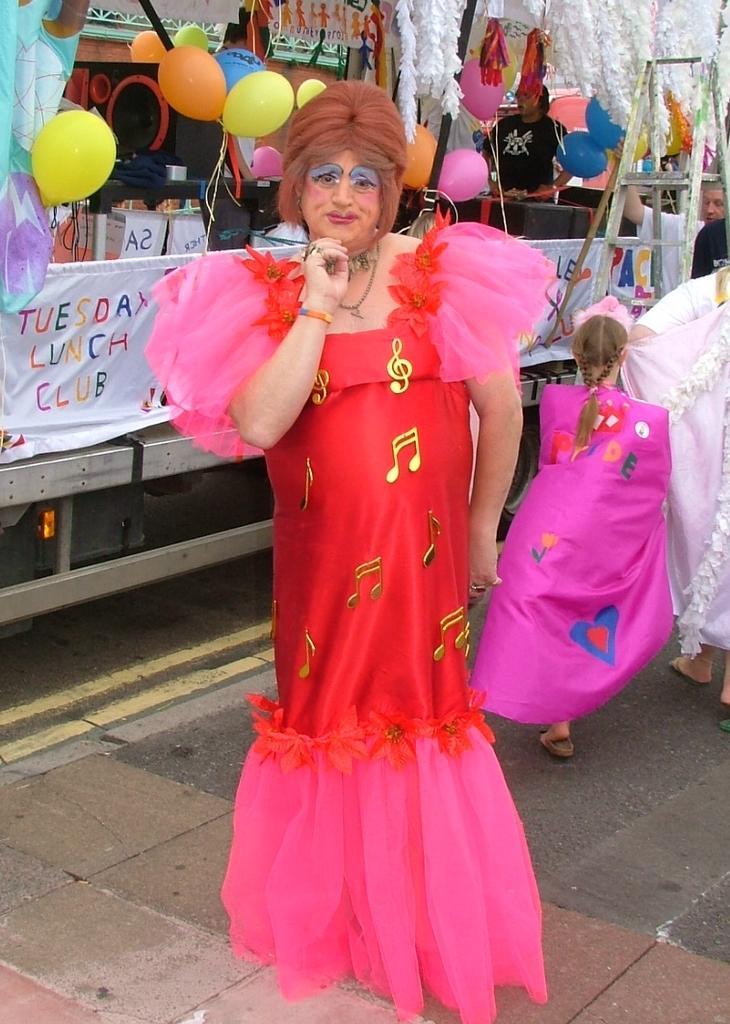Could you give a brief overview of what you see in this image? In this image there is a woman standing on the floor by wearing the red colour costume. In the background there are balloons and some decorative items. On the right side there is a girl walking on the floor. On the right side top there is a man holding the ladder. 